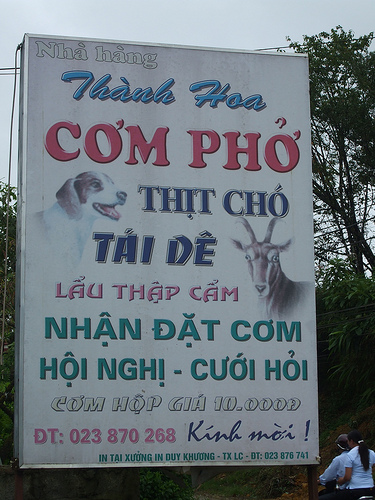<image>
Is there a dog above the goat? Yes. The dog is positioned above the goat in the vertical space, higher up in the scene. 